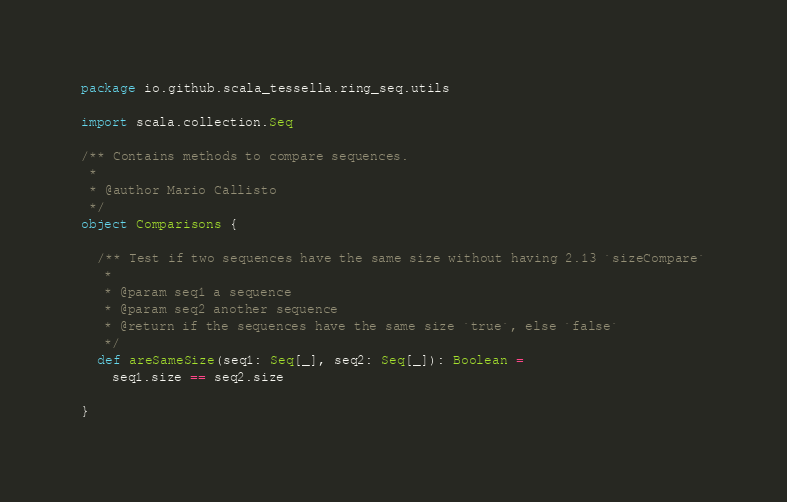Convert code to text. <code><loc_0><loc_0><loc_500><loc_500><_Scala_>package io.github.scala_tessella.ring_seq.utils

import scala.collection.Seq

/** Contains methods to compare sequences.
 *
 * @author Mario Càllisto
 */
object Comparisons {

  /** Test if two sequences have the same size without having 2.13 `sizeCompare`
   *
   * @param seq1 a sequence
   * @param seq2 another sequence
   * @return if the sequences have the same size `true`, else `false`
   */
  def areSameSize(seq1: Seq[_], seq2: Seq[_]): Boolean =
    seq1.size == seq2.size

}
</code> 